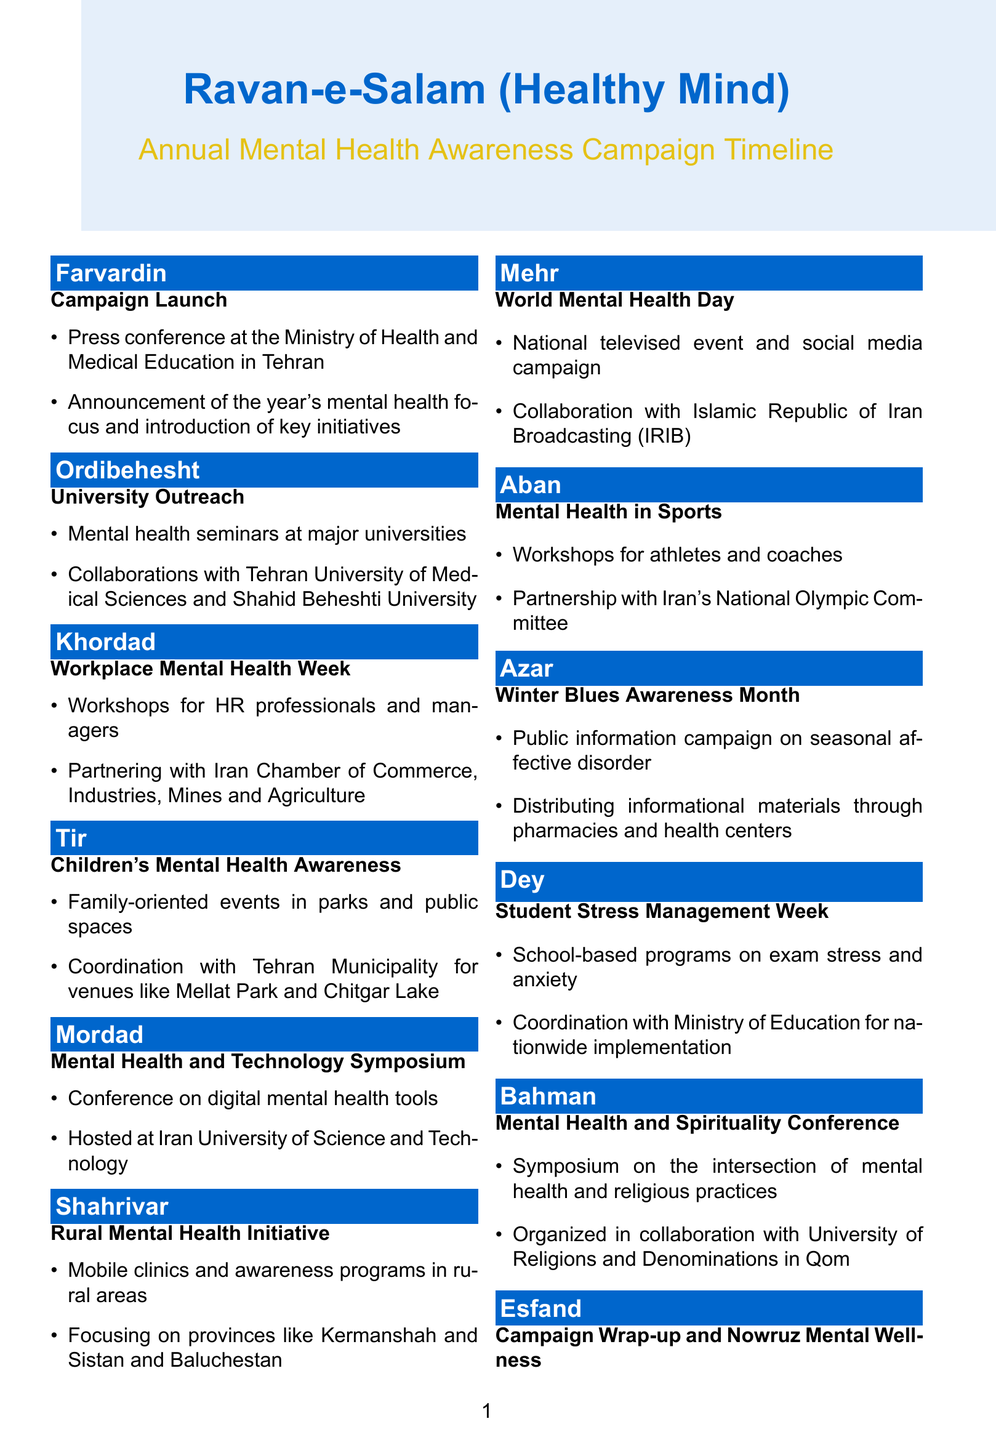What is the name of the campaign? The name of the campaign is mentioned at the beginning of the document.
Answer: Ravan-e-Salam (Healthy Mind) When does the Campaign Launch occur? The specific month of the Campaign Launch is detailed in the timeline.
Answer: Farvardin What type of events are held in Tir? The events in Tir are explicitly listed in relation to children's mental health awareness.
Answer: Family-oriented events Which universities are involved in the University Outreach? The document specifically mentions the universities collaborating on this initiative.
Answer: Tehran University of Medical Sciences and Shahid Beheshti University In which month is World Mental Health Day recognized? The document clearly states the month in relation to World Mental Health Day.
Answer: Mehr What type of workshops are conducted for athletes? The document describes the focus of the workshops for athletes and coaches.
Answer: Mental Health in Sports How many major events are planned for the year? By counting the entries in the timeline, we can determine the number of events scheduled.
Answer: Twelve Which initiative focuses on rural areas? This inquiry is about the specific initiative mentioned in the timeline for rural outreach.
Answer: Rural Mental Health Initiative What is the final event of the campaign in Esfand? The document specifies what occurs at the end of the campaign in Esfand.
Answer: Campaign Wrap-up and Nowruz Mental Wellness 